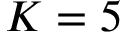Convert formula to latex. <formula><loc_0><loc_0><loc_500><loc_500>K = 5</formula> 